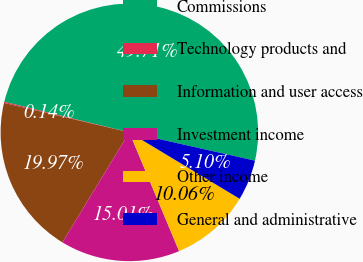Convert chart. <chart><loc_0><loc_0><loc_500><loc_500><pie_chart><fcel>Commissions<fcel>Technology products and<fcel>Information and user access<fcel>Investment income<fcel>Other income<fcel>General and administrative<nl><fcel>49.71%<fcel>0.14%<fcel>19.97%<fcel>15.01%<fcel>10.06%<fcel>5.1%<nl></chart> 